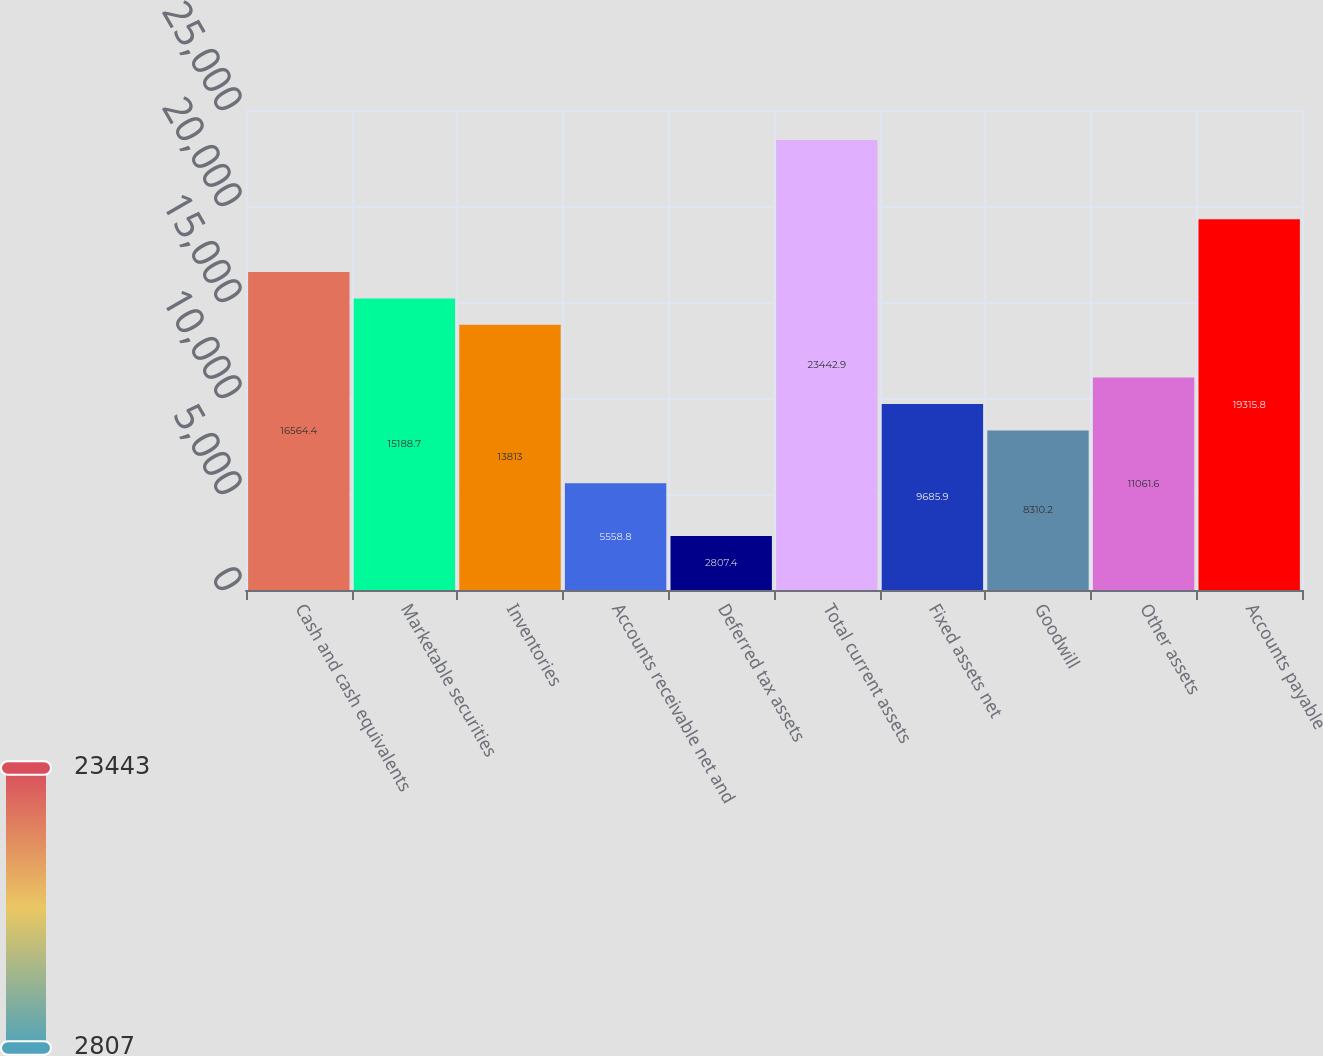Convert chart. <chart><loc_0><loc_0><loc_500><loc_500><bar_chart><fcel>Cash and cash equivalents<fcel>Marketable securities<fcel>Inventories<fcel>Accounts receivable net and<fcel>Deferred tax assets<fcel>Total current assets<fcel>Fixed assets net<fcel>Goodwill<fcel>Other assets<fcel>Accounts payable<nl><fcel>16564.4<fcel>15188.7<fcel>13813<fcel>5558.8<fcel>2807.4<fcel>23442.9<fcel>9685.9<fcel>8310.2<fcel>11061.6<fcel>19315.8<nl></chart> 